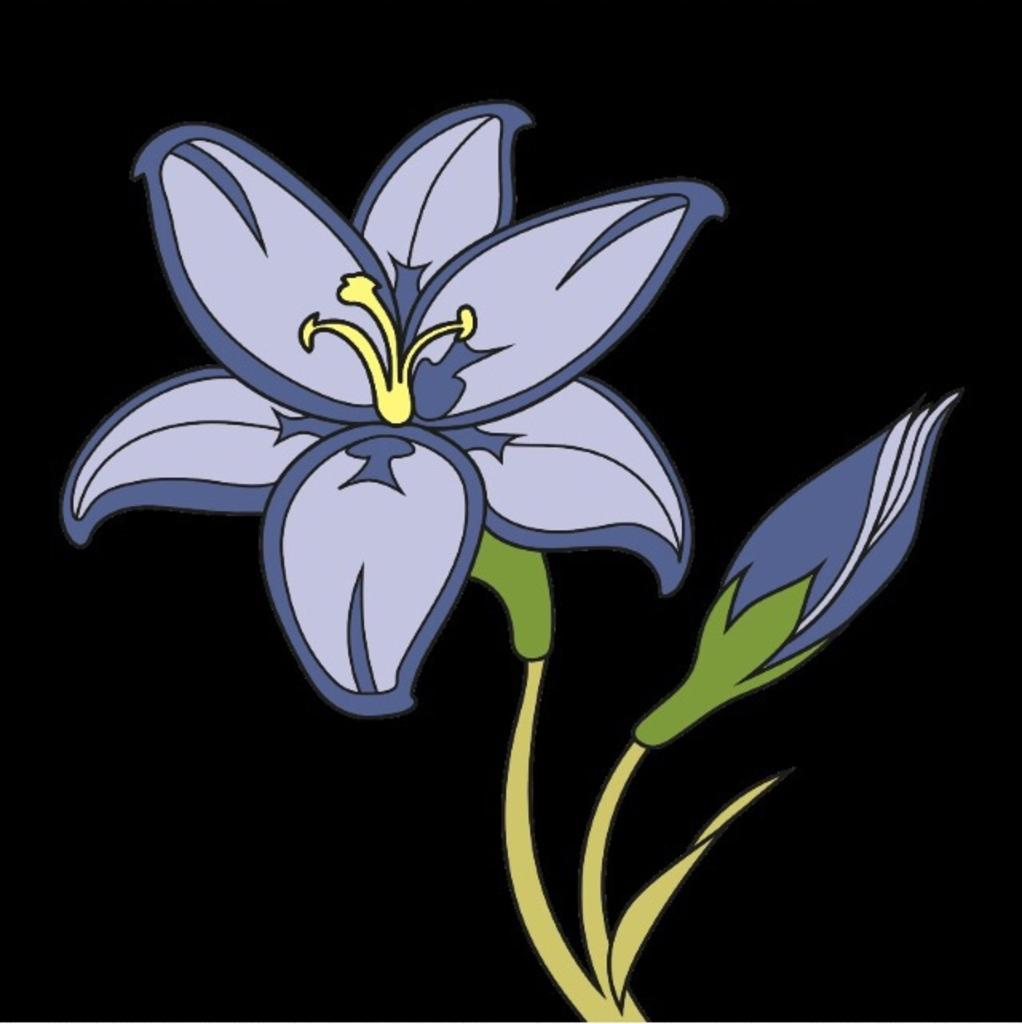What type of plant can be seen in the image? There is a flower in the image. Can you describe the stage of development of the flower? There is a bud in the image, which suggests that the flower is in the process of blooming. What is the color of the background in the image? The background of the image is dark. What type of dock can be seen in the image? There is no dock present in the image. What type of polish is being applied to the flower in the image? There is no polish being applied to the flower in the image; it is a natural plant. 